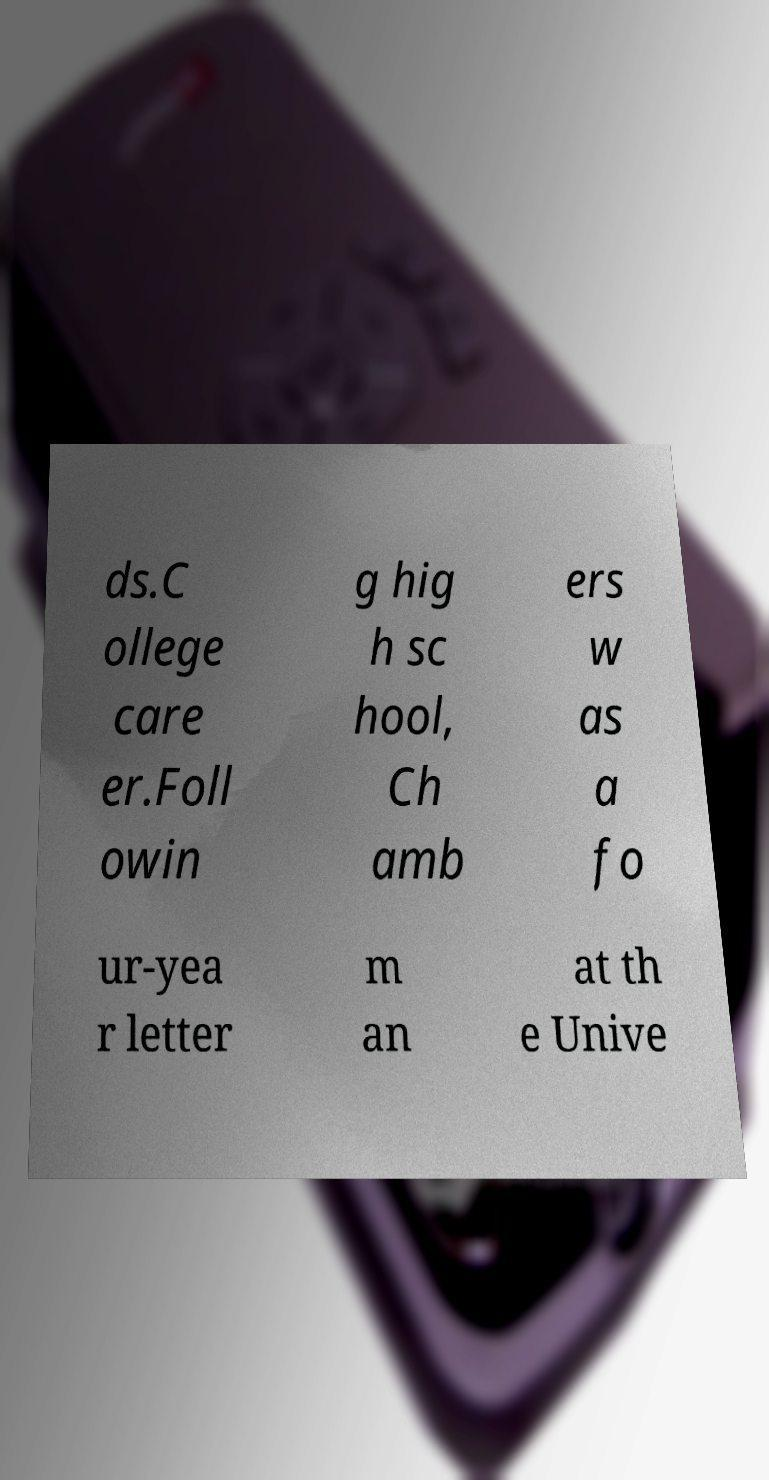Please identify and transcribe the text found in this image. ds.C ollege care er.Foll owin g hig h sc hool, Ch amb ers w as a fo ur-yea r letter m an at th e Unive 